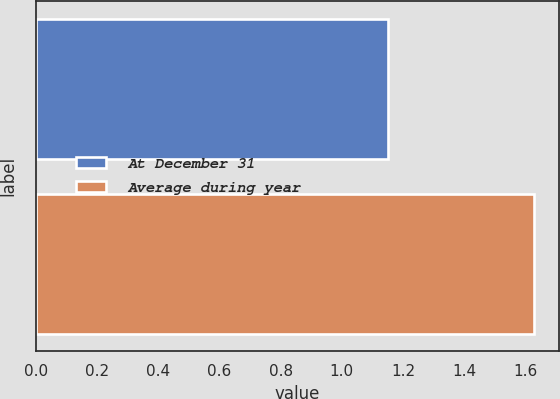<chart> <loc_0><loc_0><loc_500><loc_500><bar_chart><fcel>At December 31<fcel>Average during year<nl><fcel>1.15<fcel>1.63<nl></chart> 